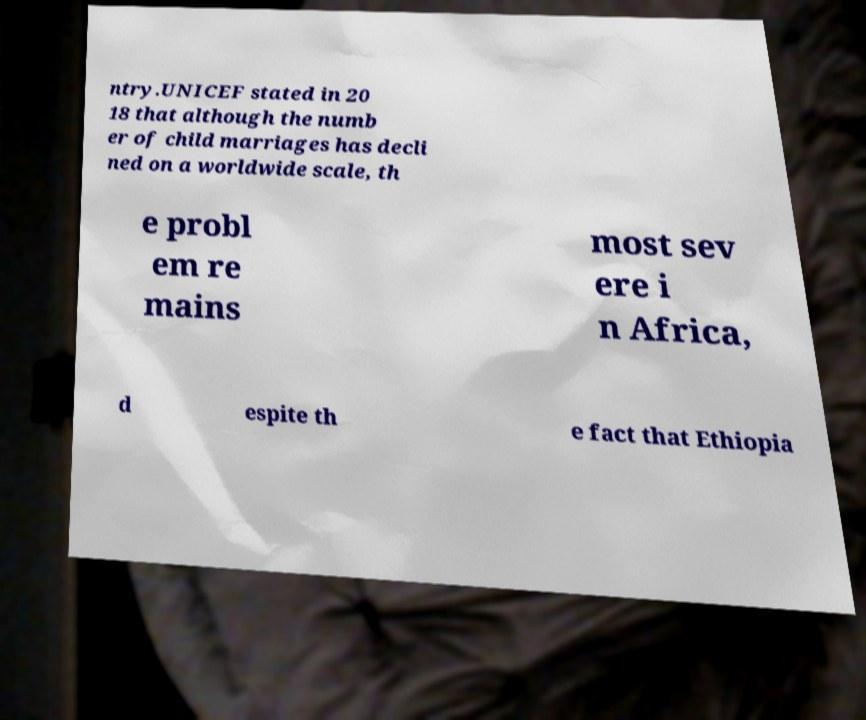What messages or text are displayed in this image? I need them in a readable, typed format. ntry.UNICEF stated in 20 18 that although the numb er of child marriages has decli ned on a worldwide scale, th e probl em re mains most sev ere i n Africa, d espite th e fact that Ethiopia 